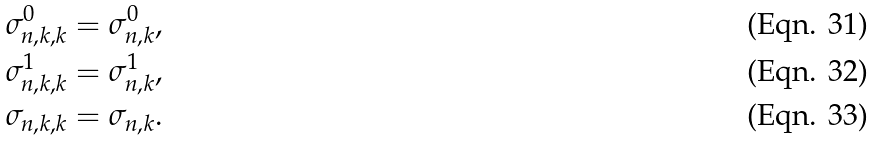<formula> <loc_0><loc_0><loc_500><loc_500>\sigma _ { n , k , k } ^ { 0 } & = \sigma _ { n , k } ^ { 0 } , \\ \sigma _ { n , k , k } ^ { 1 } & = \sigma _ { n , k } ^ { 1 } , \\ \sigma _ { n , k , k } & = \sigma _ { n , k } .</formula> 